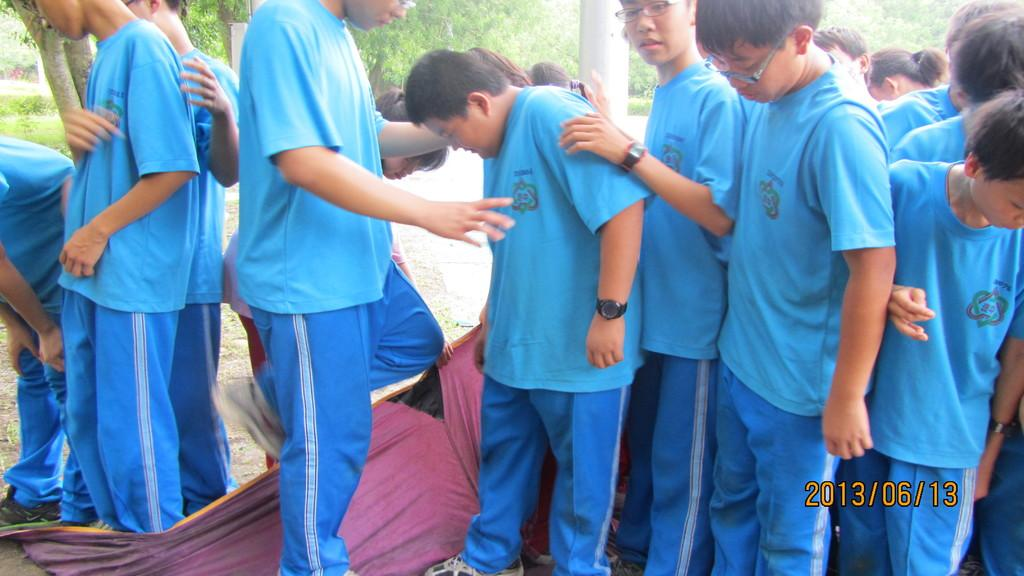What type of material is present in the image? There is cloth in the image. What natural elements can be seen in the image? There are trees and grass in the image. Who is present in the image? There is a group of people in the image. What color are the t-shirts worn by the people in the image? The people are wearing sky blue color t-shirts. What type of plantation is visible in the image? There is no plantation present in the image; it features cloth, trees, grass, and a group of people wearing sky blue t-shirts. What government policies are being discussed by the group of people in the image? There is no indication of any discussion or government policies in the image; it only shows a group of people wearing sky blue t-shirts. 